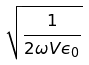Convert formula to latex. <formula><loc_0><loc_0><loc_500><loc_500>\sqrt { \frac { 1 } { 2 \omega V \epsilon _ { 0 } } }</formula> 